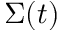<formula> <loc_0><loc_0><loc_500><loc_500>\Sigma ( t )</formula> 